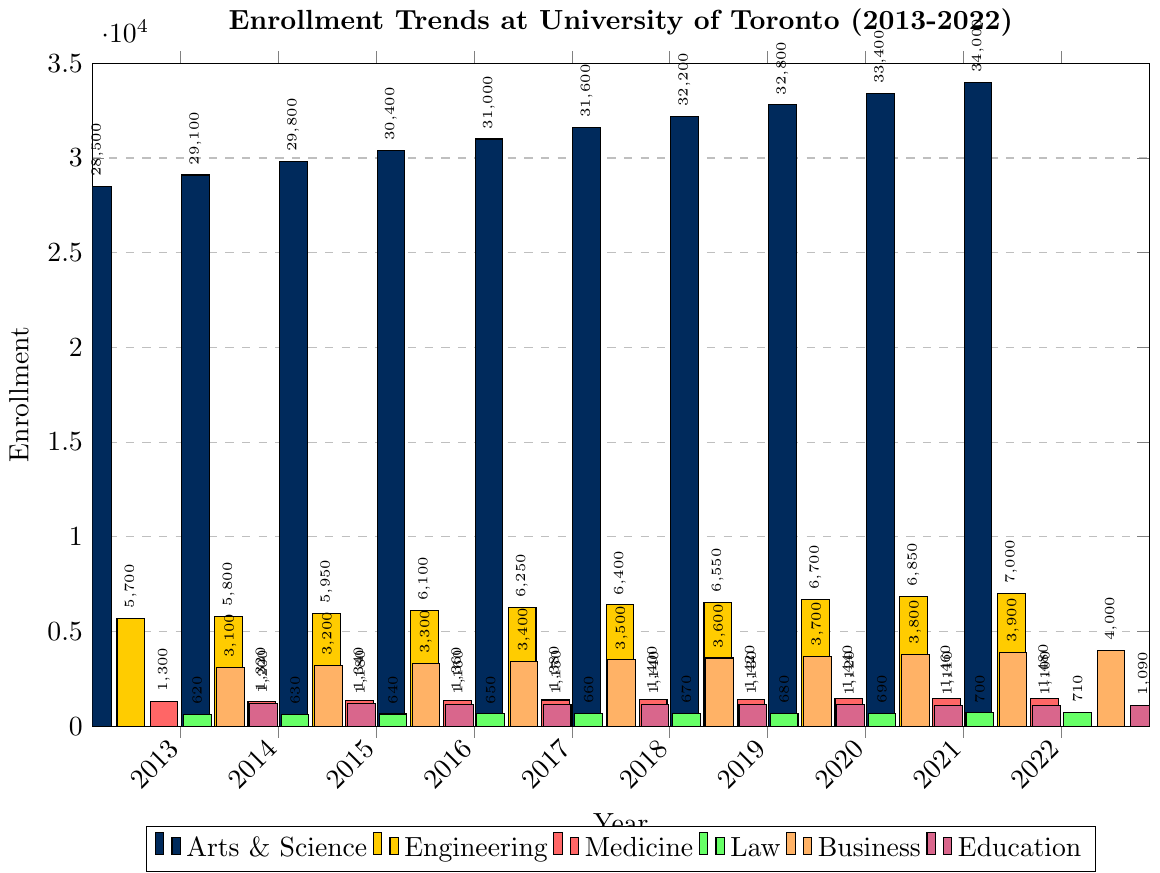What is the trend in enrollment for the Engineering faculty from 2013 to 2022? The bars for Engineering show a steady increase over the years, starting at 5,700 in 2013 and reaching 7,000 in 2022. The growth is consistent without any declines.
Answer: Steady increase Which faculty had the highest enrollment in 2022? The Arts & Science faculty has the tallest bar in 2022, indicating it had the highest enrollment.
Answer: Arts & Science Compare the enrollment trends of Medicine and Law between 2013 and 2022. Both faculties show a gradual increase over the decade. Medicine starts at 1,300 in 2013 and increases to 1,480 in 2022. Law starts at 620 in 2013 and rises to 710 in 2022. While both have similar upward trends, the absolute numbers for Medicine are higher throughout.
Answer: Medicine has consistently higher enrollment How much did the enrollment for Business faculty increase from 2013 to 2022? The enrollment for Business in 2013 was 3,100 and increased to 4,000 in 2022. The difference is 4,000 - 3,100 = 900.
Answer: 900 Which faculty shows the most stable enrollment numbers throughout the years? The Education faculty shows the least fluctuation with enrollment numbers only slightly decreasing from 1,200 in 2013 to 1,090 in 2022, suggesting stability compared to others.
Answer: Education What is the combined enrollment for Arts & Science and Engineering in 2013 and 2022? For 2013: Arts & Science = 28,500, Engineering = 5,700. Combined = 28,500 + 5,700 = 34,200. For 2022: Arts & Science = 34,000, Engineering = 7,000. Combined = 34,000 + 7,000 = 41,000.
Answer: 34,200 in 2013, 41,000 in 2022 Which faculty experienced a decline in enrollment from 2013 to 2022? Education shows a decline from 1,200 in 2013 to 1,090 in 2022.
Answer: Education Between which consecutive years did Business faculty see the greatest increase in enrollment? From 2021 to 2022, Business faculty enrollment increased from 3,900 to 4,000, which is an increase of 100. This is the largest one-year increase observed for the Business faculty.
Answer: 2021 to 2022 